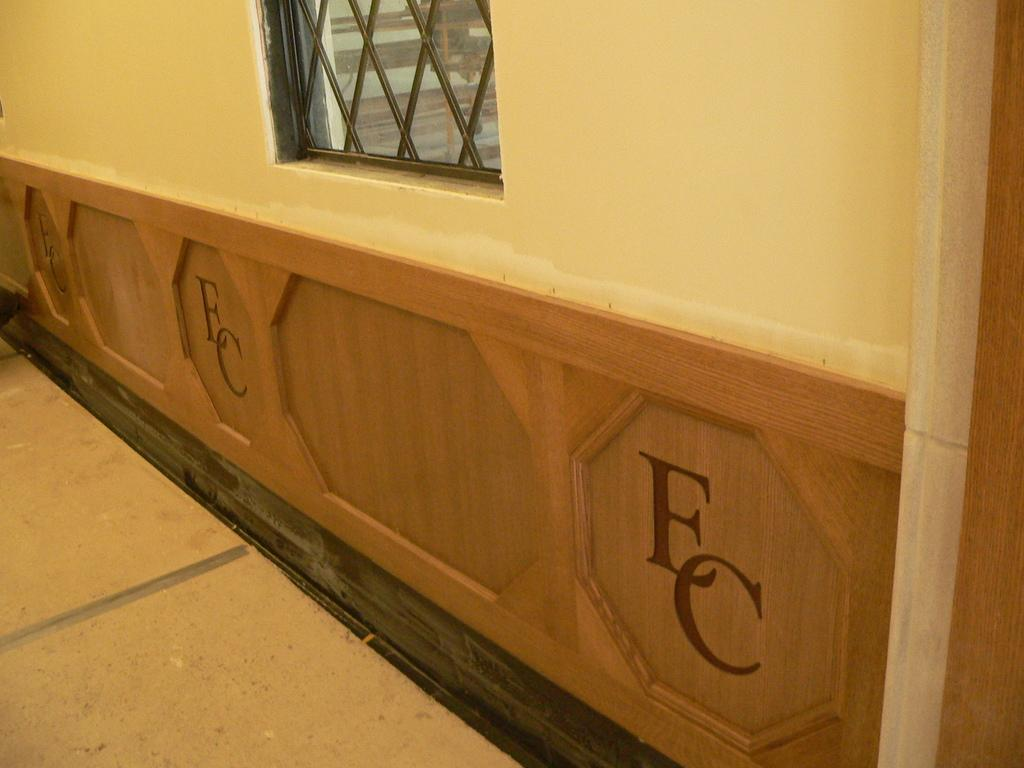What is a prominent feature of the wall in the image? There is a window on the wall in the image. Is there any text on the wall? Yes, there is text written on the wall. What type of silk fabric is used to cover the wall in the image? There is no silk fabric present in the image; the wall is covered with text and a window. 